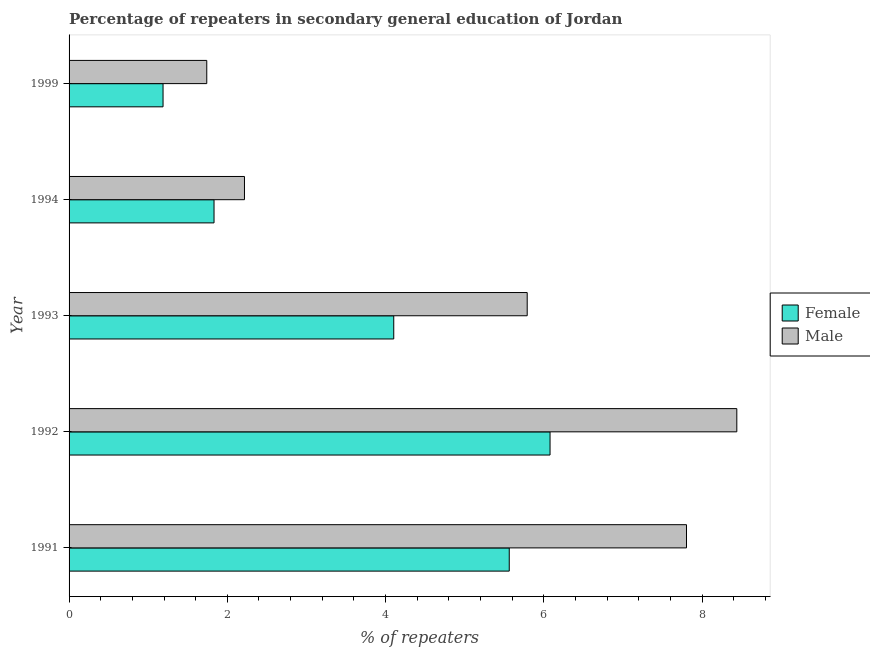How many different coloured bars are there?
Keep it short and to the point. 2. Are the number of bars on each tick of the Y-axis equal?
Ensure brevity in your answer.  Yes. How many bars are there on the 3rd tick from the top?
Your answer should be very brief. 2. What is the label of the 4th group of bars from the top?
Provide a succinct answer. 1992. What is the percentage of male repeaters in 1994?
Ensure brevity in your answer.  2.22. Across all years, what is the maximum percentage of male repeaters?
Keep it short and to the point. 8.44. Across all years, what is the minimum percentage of male repeaters?
Ensure brevity in your answer.  1.74. In which year was the percentage of male repeaters maximum?
Provide a succinct answer. 1992. In which year was the percentage of female repeaters minimum?
Offer a terse response. 1999. What is the total percentage of female repeaters in the graph?
Give a very brief answer. 18.77. What is the difference between the percentage of male repeaters in 1992 and that in 1993?
Make the answer very short. 2.65. What is the difference between the percentage of female repeaters in 1991 and the percentage of male repeaters in 1999?
Offer a terse response. 3.82. What is the average percentage of male repeaters per year?
Provide a succinct answer. 5.2. In the year 1993, what is the difference between the percentage of female repeaters and percentage of male repeaters?
Give a very brief answer. -1.69. What is the ratio of the percentage of female repeaters in 1991 to that in 1994?
Provide a short and direct response. 3.04. Is the difference between the percentage of male repeaters in 1992 and 1994 greater than the difference between the percentage of female repeaters in 1992 and 1994?
Keep it short and to the point. Yes. What is the difference between the highest and the second highest percentage of male repeaters?
Provide a succinct answer. 0.64. In how many years, is the percentage of female repeaters greater than the average percentage of female repeaters taken over all years?
Provide a short and direct response. 3. Is the sum of the percentage of female repeaters in 1991 and 1993 greater than the maximum percentage of male repeaters across all years?
Provide a succinct answer. Yes. What does the 1st bar from the bottom in 1999 represents?
Provide a short and direct response. Female. Are all the bars in the graph horizontal?
Give a very brief answer. Yes. How many years are there in the graph?
Ensure brevity in your answer.  5. What is the difference between two consecutive major ticks on the X-axis?
Offer a very short reply. 2. Are the values on the major ticks of X-axis written in scientific E-notation?
Provide a succinct answer. No. How are the legend labels stacked?
Your response must be concise. Vertical. What is the title of the graph?
Give a very brief answer. Percentage of repeaters in secondary general education of Jordan. What is the label or title of the X-axis?
Provide a short and direct response. % of repeaters. What is the % of repeaters in Female in 1991?
Offer a terse response. 5.56. What is the % of repeaters of Male in 1991?
Give a very brief answer. 7.8. What is the % of repeaters of Female in 1992?
Give a very brief answer. 6.08. What is the % of repeaters of Male in 1992?
Ensure brevity in your answer.  8.44. What is the % of repeaters of Female in 1993?
Give a very brief answer. 4.1. What is the % of repeaters of Male in 1993?
Offer a terse response. 5.79. What is the % of repeaters of Female in 1994?
Your response must be concise. 1.83. What is the % of repeaters of Male in 1994?
Give a very brief answer. 2.22. What is the % of repeaters of Female in 1999?
Your answer should be very brief. 1.19. What is the % of repeaters of Male in 1999?
Give a very brief answer. 1.74. Across all years, what is the maximum % of repeaters of Female?
Ensure brevity in your answer.  6.08. Across all years, what is the maximum % of repeaters of Male?
Offer a terse response. 8.44. Across all years, what is the minimum % of repeaters in Female?
Ensure brevity in your answer.  1.19. Across all years, what is the minimum % of repeaters in Male?
Provide a succinct answer. 1.74. What is the total % of repeaters of Female in the graph?
Give a very brief answer. 18.77. What is the total % of repeaters in Male in the graph?
Keep it short and to the point. 25.99. What is the difference between the % of repeaters of Female in 1991 and that in 1992?
Make the answer very short. -0.52. What is the difference between the % of repeaters in Male in 1991 and that in 1992?
Give a very brief answer. -0.64. What is the difference between the % of repeaters of Female in 1991 and that in 1993?
Offer a terse response. 1.46. What is the difference between the % of repeaters in Male in 1991 and that in 1993?
Make the answer very short. 2.01. What is the difference between the % of repeaters in Female in 1991 and that in 1994?
Make the answer very short. 3.73. What is the difference between the % of repeaters in Male in 1991 and that in 1994?
Offer a terse response. 5.59. What is the difference between the % of repeaters in Female in 1991 and that in 1999?
Ensure brevity in your answer.  4.38. What is the difference between the % of repeaters of Male in 1991 and that in 1999?
Give a very brief answer. 6.06. What is the difference between the % of repeaters in Female in 1992 and that in 1993?
Your response must be concise. 1.98. What is the difference between the % of repeaters in Male in 1992 and that in 1993?
Keep it short and to the point. 2.65. What is the difference between the % of repeaters in Female in 1992 and that in 1994?
Your answer should be very brief. 4.25. What is the difference between the % of repeaters in Male in 1992 and that in 1994?
Your answer should be very brief. 6.22. What is the difference between the % of repeaters in Female in 1992 and that in 1999?
Provide a succinct answer. 4.89. What is the difference between the % of repeaters of Male in 1992 and that in 1999?
Give a very brief answer. 6.7. What is the difference between the % of repeaters in Female in 1993 and that in 1994?
Give a very brief answer. 2.27. What is the difference between the % of repeaters of Male in 1993 and that in 1994?
Make the answer very short. 3.57. What is the difference between the % of repeaters of Female in 1993 and that in 1999?
Offer a terse response. 2.92. What is the difference between the % of repeaters in Male in 1993 and that in 1999?
Your response must be concise. 4.05. What is the difference between the % of repeaters of Female in 1994 and that in 1999?
Give a very brief answer. 0.64. What is the difference between the % of repeaters in Male in 1994 and that in 1999?
Your response must be concise. 0.48. What is the difference between the % of repeaters of Female in 1991 and the % of repeaters of Male in 1992?
Your response must be concise. -2.88. What is the difference between the % of repeaters in Female in 1991 and the % of repeaters in Male in 1993?
Keep it short and to the point. -0.23. What is the difference between the % of repeaters in Female in 1991 and the % of repeaters in Male in 1994?
Provide a succinct answer. 3.35. What is the difference between the % of repeaters of Female in 1991 and the % of repeaters of Male in 1999?
Ensure brevity in your answer.  3.82. What is the difference between the % of repeaters in Female in 1992 and the % of repeaters in Male in 1993?
Provide a succinct answer. 0.29. What is the difference between the % of repeaters in Female in 1992 and the % of repeaters in Male in 1994?
Make the answer very short. 3.86. What is the difference between the % of repeaters of Female in 1992 and the % of repeaters of Male in 1999?
Provide a succinct answer. 4.34. What is the difference between the % of repeaters in Female in 1993 and the % of repeaters in Male in 1994?
Offer a very short reply. 1.89. What is the difference between the % of repeaters of Female in 1993 and the % of repeaters of Male in 1999?
Your answer should be very brief. 2.36. What is the difference between the % of repeaters in Female in 1994 and the % of repeaters in Male in 1999?
Give a very brief answer. 0.09. What is the average % of repeaters of Female per year?
Make the answer very short. 3.75. What is the average % of repeaters of Male per year?
Offer a terse response. 5.2. In the year 1991, what is the difference between the % of repeaters in Female and % of repeaters in Male?
Your answer should be compact. -2.24. In the year 1992, what is the difference between the % of repeaters of Female and % of repeaters of Male?
Offer a very short reply. -2.36. In the year 1993, what is the difference between the % of repeaters of Female and % of repeaters of Male?
Your answer should be very brief. -1.69. In the year 1994, what is the difference between the % of repeaters in Female and % of repeaters in Male?
Ensure brevity in your answer.  -0.38. In the year 1999, what is the difference between the % of repeaters in Female and % of repeaters in Male?
Provide a succinct answer. -0.55. What is the ratio of the % of repeaters of Female in 1991 to that in 1992?
Offer a terse response. 0.92. What is the ratio of the % of repeaters in Male in 1991 to that in 1992?
Your answer should be very brief. 0.92. What is the ratio of the % of repeaters of Female in 1991 to that in 1993?
Your answer should be compact. 1.36. What is the ratio of the % of repeaters of Male in 1991 to that in 1993?
Offer a terse response. 1.35. What is the ratio of the % of repeaters in Female in 1991 to that in 1994?
Provide a short and direct response. 3.04. What is the ratio of the % of repeaters in Male in 1991 to that in 1994?
Provide a succinct answer. 3.52. What is the ratio of the % of repeaters in Female in 1991 to that in 1999?
Offer a very short reply. 4.68. What is the ratio of the % of repeaters of Male in 1991 to that in 1999?
Make the answer very short. 4.48. What is the ratio of the % of repeaters of Female in 1992 to that in 1993?
Offer a terse response. 1.48. What is the ratio of the % of repeaters in Male in 1992 to that in 1993?
Ensure brevity in your answer.  1.46. What is the ratio of the % of repeaters in Female in 1992 to that in 1994?
Provide a succinct answer. 3.32. What is the ratio of the % of repeaters in Male in 1992 to that in 1994?
Offer a terse response. 3.81. What is the ratio of the % of repeaters in Female in 1992 to that in 1999?
Make the answer very short. 5.12. What is the ratio of the % of repeaters of Male in 1992 to that in 1999?
Offer a very short reply. 4.85. What is the ratio of the % of repeaters of Female in 1993 to that in 1994?
Your answer should be compact. 2.24. What is the ratio of the % of repeaters in Male in 1993 to that in 1994?
Your response must be concise. 2.61. What is the ratio of the % of repeaters of Female in 1993 to that in 1999?
Your answer should be very brief. 3.46. What is the ratio of the % of repeaters of Male in 1993 to that in 1999?
Offer a very short reply. 3.33. What is the ratio of the % of repeaters of Female in 1994 to that in 1999?
Your answer should be very brief. 1.54. What is the ratio of the % of repeaters of Male in 1994 to that in 1999?
Offer a terse response. 1.27. What is the difference between the highest and the second highest % of repeaters of Female?
Offer a terse response. 0.52. What is the difference between the highest and the second highest % of repeaters of Male?
Provide a short and direct response. 0.64. What is the difference between the highest and the lowest % of repeaters in Female?
Ensure brevity in your answer.  4.89. What is the difference between the highest and the lowest % of repeaters in Male?
Offer a very short reply. 6.7. 